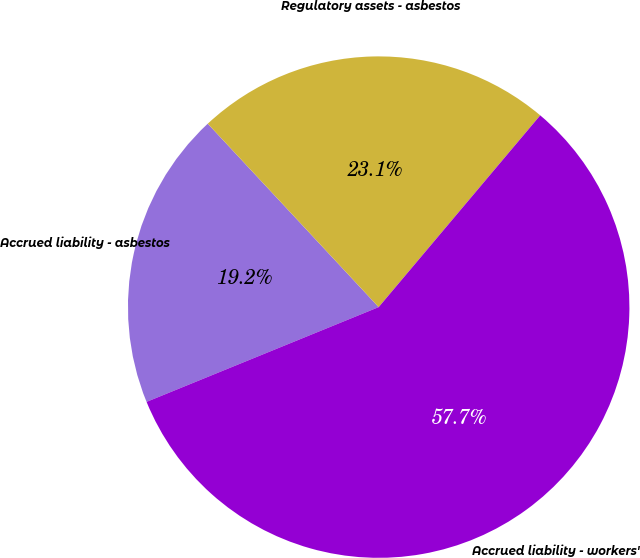Convert chart to OTSL. <chart><loc_0><loc_0><loc_500><loc_500><pie_chart><fcel>Accrued liability - asbestos<fcel>Regulatory assets - asbestos<fcel>Accrued liability - workers'<nl><fcel>19.23%<fcel>23.08%<fcel>57.69%<nl></chart> 